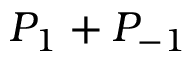Convert formula to latex. <formula><loc_0><loc_0><loc_500><loc_500>P _ { 1 } + P _ { - 1 }</formula> 